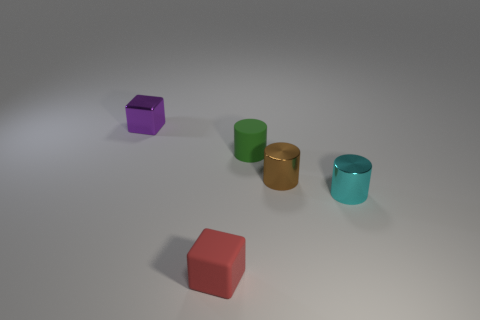Subtract all tiny shiny cylinders. How many cylinders are left? 1 Subtract all brown cylinders. How many cylinders are left? 2 Add 1 large green balls. How many objects exist? 6 Subtract 1 cyan cylinders. How many objects are left? 4 Subtract all blocks. How many objects are left? 3 Subtract 1 cubes. How many cubes are left? 1 Subtract all purple cubes. Subtract all green spheres. How many cubes are left? 1 Subtract all red cubes. How many gray cylinders are left? 0 Subtract all big cyan balls. Subtract all cyan shiny objects. How many objects are left? 4 Add 3 metallic cylinders. How many metallic cylinders are left? 5 